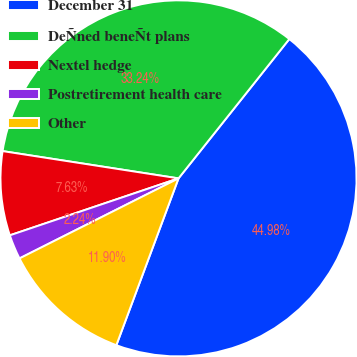Convert chart. <chart><loc_0><loc_0><loc_500><loc_500><pie_chart><fcel>December 31<fcel>DeÑned beneÑt plans<fcel>Nextel hedge<fcel>Postretirement health care<fcel>Other<nl><fcel>44.98%<fcel>33.24%<fcel>7.63%<fcel>2.24%<fcel>11.9%<nl></chart> 